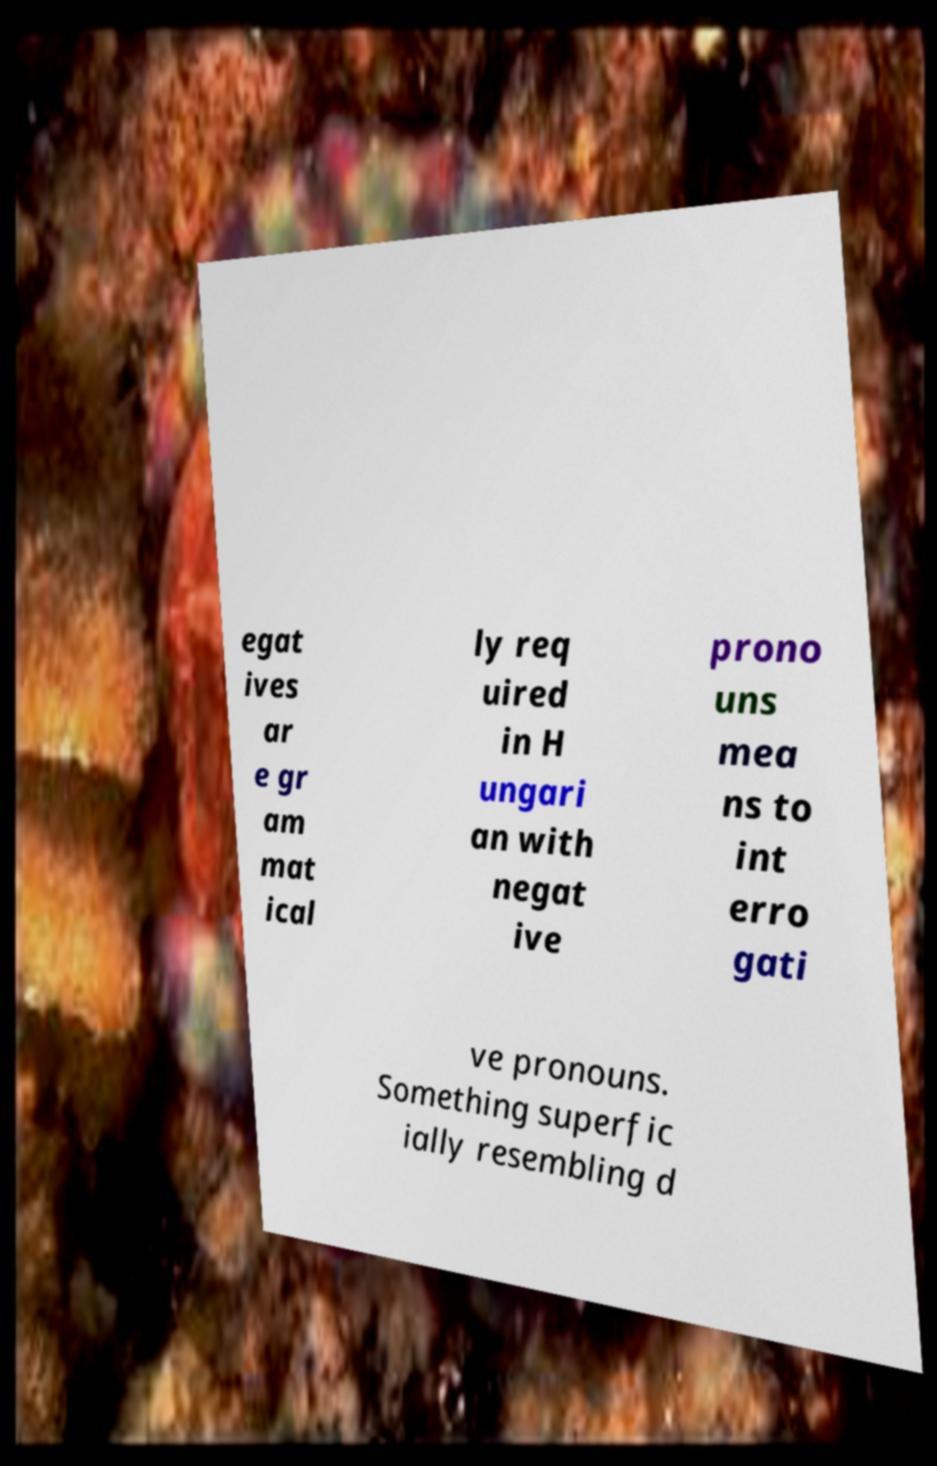Can you read and provide the text displayed in the image?This photo seems to have some interesting text. Can you extract and type it out for me? egat ives ar e gr am mat ical ly req uired in H ungari an with negat ive prono uns mea ns to int erro gati ve pronouns. Something superfic ially resembling d 